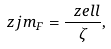Convert formula to latex. <formula><loc_0><loc_0><loc_500><loc_500>\ z j m _ { F } = \frac { \ z e l l } { \zeta } ,</formula> 